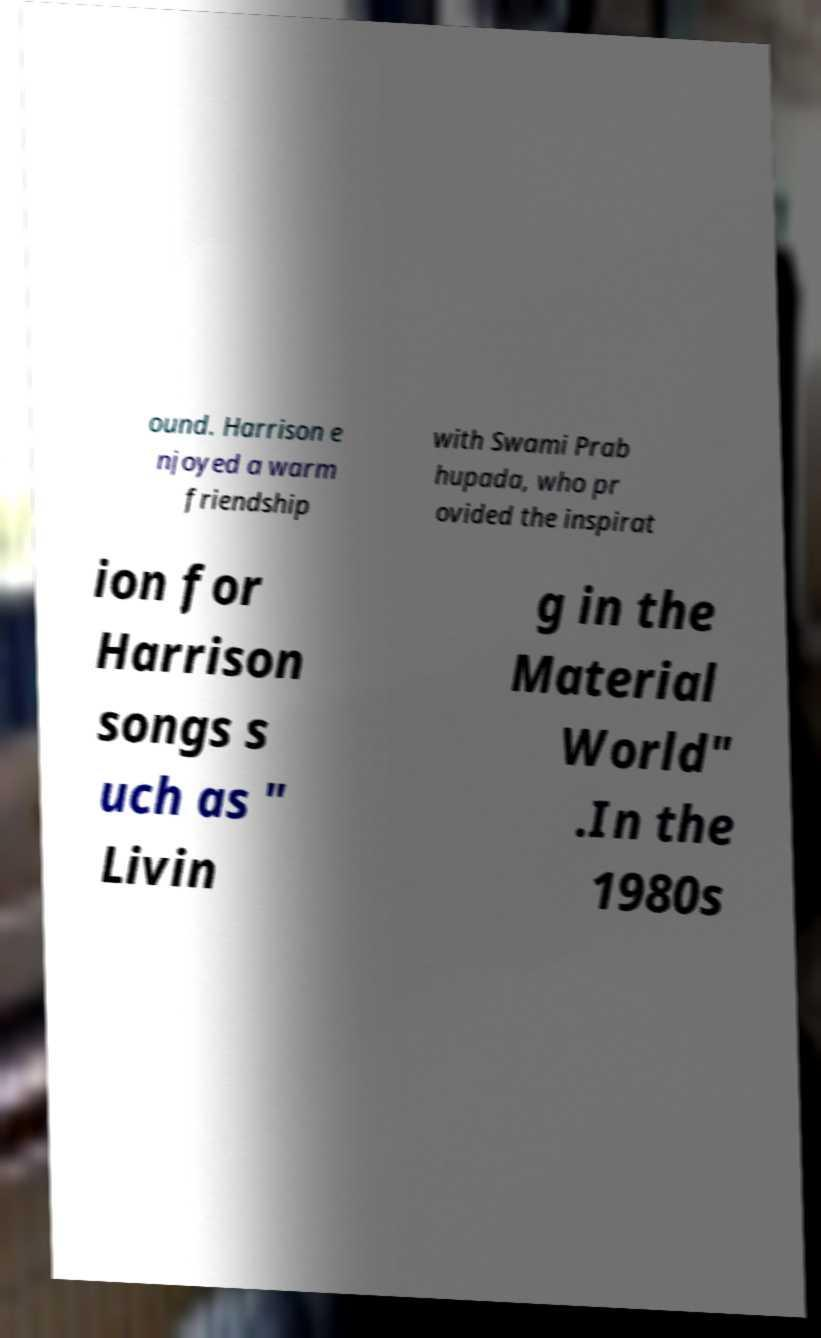There's text embedded in this image that I need extracted. Can you transcribe it verbatim? ound. Harrison e njoyed a warm friendship with Swami Prab hupada, who pr ovided the inspirat ion for Harrison songs s uch as " Livin g in the Material World" .In the 1980s 